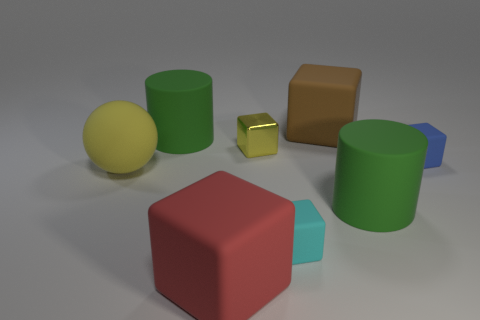Is there any other thing that is made of the same material as the tiny yellow thing?
Make the answer very short. No. Is there a shiny cube that has the same size as the shiny object?
Make the answer very short. No. The other big cube that is made of the same material as the large brown block is what color?
Offer a terse response. Red. What is the material of the tiny yellow block?
Provide a short and direct response. Metal. The yellow matte thing has what shape?
Keep it short and to the point. Sphere. What number of spheres are the same color as the metallic object?
Your answer should be compact. 1. What is the material of the big green cylinder right of the tiny thing in front of the large sphere that is to the left of the big brown matte thing?
Provide a succinct answer. Rubber. What number of green things are either large matte cubes or rubber cylinders?
Keep it short and to the point. 2. What is the size of the metallic block right of the green rubber cylinder that is behind the cube that is right of the large brown matte thing?
Provide a short and direct response. Small. There is a metal object that is the same shape as the tiny cyan rubber thing; what is its size?
Offer a very short reply. Small. 